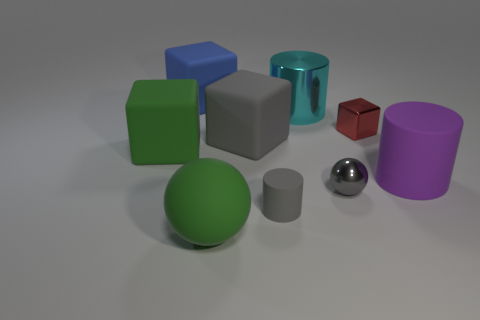Subtract all gray rubber cylinders. How many cylinders are left? 2 Subtract all gray cylinders. How many cylinders are left? 2 Subtract 0 blue balls. How many objects are left? 9 Subtract all cylinders. How many objects are left? 6 Subtract all gray cubes. Subtract all purple cylinders. How many cubes are left? 3 Subtract all brown cubes. How many green balls are left? 1 Subtract all small purple rubber objects. Subtract all big green matte blocks. How many objects are left? 8 Add 7 large purple matte cylinders. How many large purple matte cylinders are left? 8 Add 3 small shiny cubes. How many small shiny cubes exist? 4 